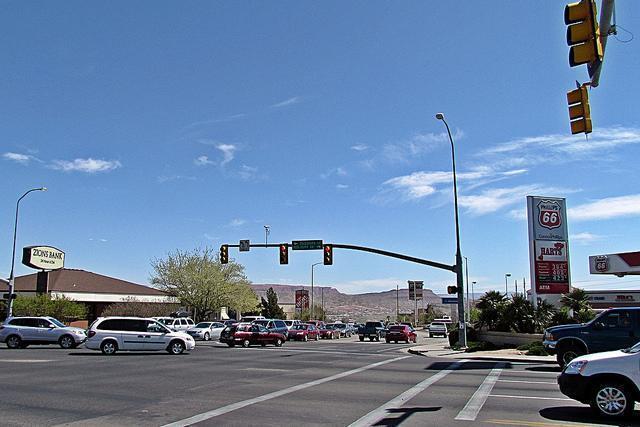What type of station is nearby?
Make your selection and explain in format: 'Answer: answer
Rationale: rationale.'
Options: Gas, bus, fire, train. Answer: gas.
Rationale: There is a sign with prices 